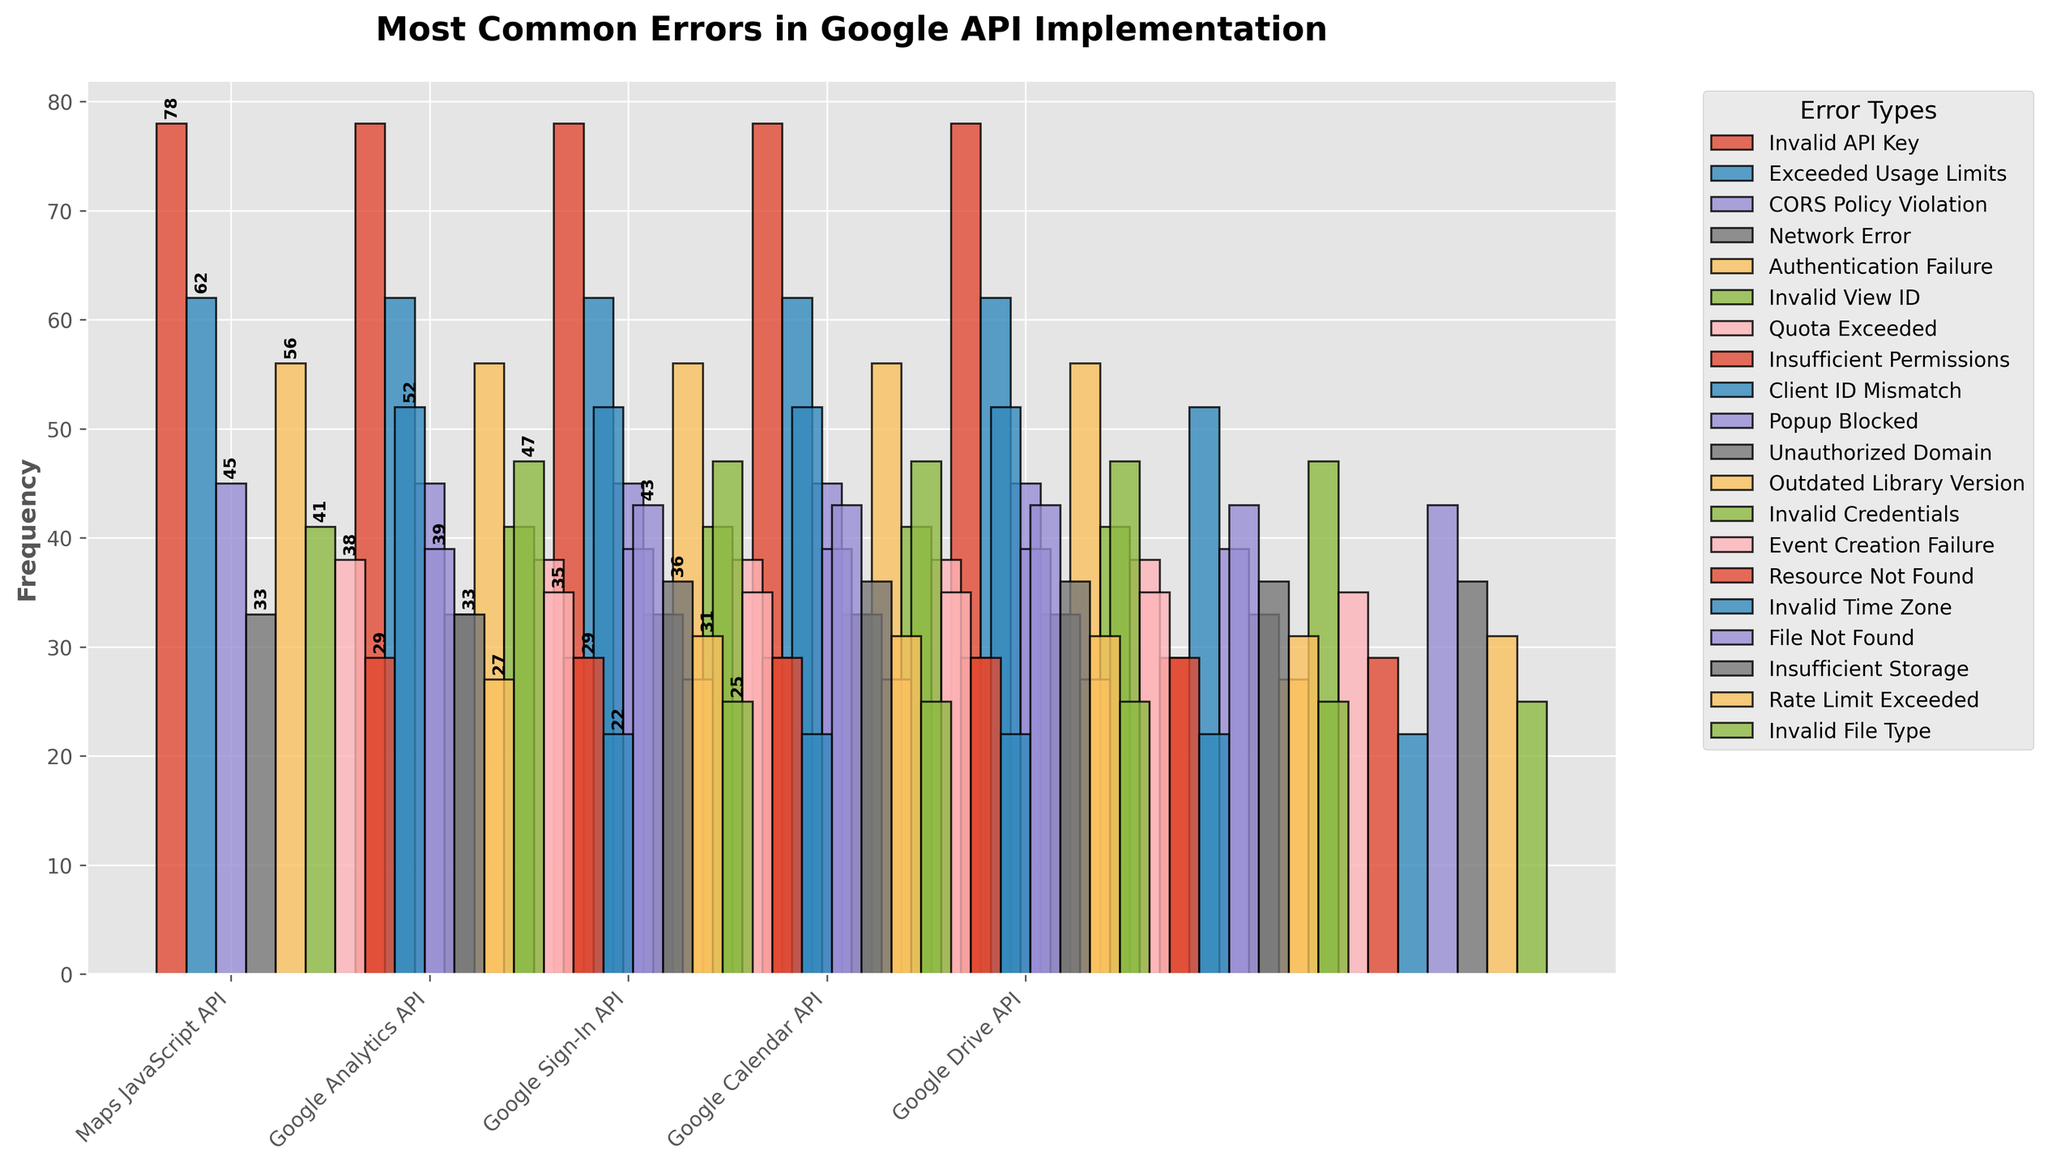Which API type has the highest frequency for 'Invalid API Key' error? To find this, look at the bars labeled 'Invalid API Key' and identify the API type with the tallest bar. The 'Maps JavaScript API' bar is the tallest at 78.
Answer: Maps JavaScript API What is the combined frequency of 'Exceeded Usage Limits' and 'Network Error' for Maps JavaScript API? Add the frequencies of 'Exceeded Usage Limits' (62) and 'Network Error' (33) for Maps JavaScript API. The combined frequency is 62 + 33 = 95.
Answer: 95 Which error type occurs more frequently in Google Sign-In API: 'Client ID Mismatch' or 'Popup Blocked'? Compare the heights of the bars for 'Client ID Mismatch' (52) and 'Popup Blocked' (39) under Google Sign-In API. 'Client ID Mismatch' has a higher frequency.
Answer: Client ID Mismatch What is the frequency difference between 'Invalid Credentials' and 'Event Creation Failure' in Google Calendar API? Subtract the frequency of 'Event Creation Failure' (35) from 'Invalid Credentials' (47) for Google Calendar API. The difference is 47 - 35 = 12.
Answer: 12 Which API type has the lowest frequency for 'Insufficient Permissions'? Identify the bar with 'Insufficient Permissions' error under Google Analytics API, which is the only API for this error type. Its frequency is 29.
Answer: Google Analytics API How many API types have at least one error with a frequency above 50? Count the API types that have at least one bar above the frequency threshold of 50. These are: Maps JavaScript API (78, 62), Google Analytics API (56), Google Sign-In API (52). So, 3 API types.
Answer: 3 What is the total frequency of errors in Google Drive API? Sum the frequencies of all errors in Google Drive API: 'File Not Found' (43), 'Insufficient Storage' (36), 'Rate Limit Exceeded' (31), 'Invalid File Type' (25). The total frequency is 43 + 36 + 31 + 25 = 135.
Answer: 135 Which error under 'Google Calendar API' has the smallest frequency? Look at the bars under Google Calendar API and find the one with the smallest height, which is 'Invalid Time Zone' with a frequency of 22.
Answer: Invalid Time Zone Is the frequency of 'Invalid API Key' greater or smaller than the sum of 'Authentication Failure' and 'Quota Exceeded' in Google Analytics API? Check the frequency of 'Invalid API Key' (78) in Maps JavaScript API. Sum the frequencies of 'Authentication Failure' (56) and 'Quota Exceeded' (38) in Google Analytics API. The sum is 56 + 38 = 94. 78 is smaller than 94.
Answer: Smaller 